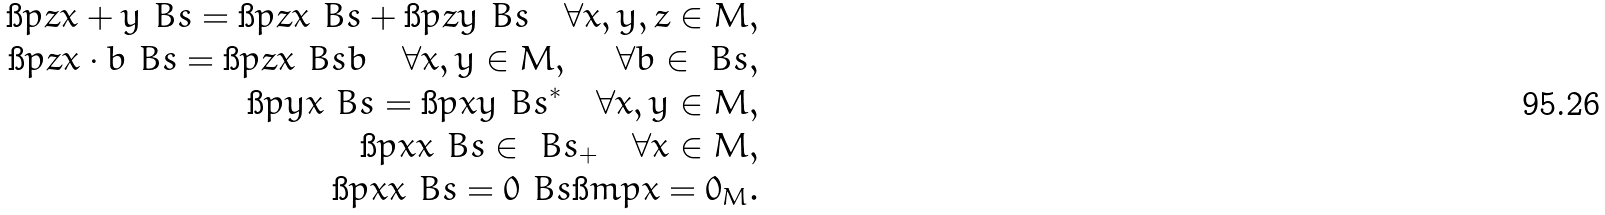Convert formula to latex. <formula><loc_0><loc_0><loc_500><loc_500>\i p { z } { x + y } _ { \ } B s = \i p { z } { x } _ { \ } B s + \i p { z } { y } _ { \ } B s \quad \forall x , y , z \in M , \\ \i p { z } { x \cdot b } _ { \ } B s = \i p { z } { x } _ { \ } B s b \quad \forall x , y \in M , \ \quad \forall b \in \ B s , \\ \i p { y } { x } _ { \ } B s = \i p { x } { y } _ { \ } B s ^ { * } \quad \forall x , y \in M , \\ \i p { x } { x } _ { \ } B s \in \ B s _ { + } \quad \forall x \in M , \\ \i p { x } { x } _ { \ } B s = 0 _ { \ } B s \i m p x = 0 _ { M } .</formula> 